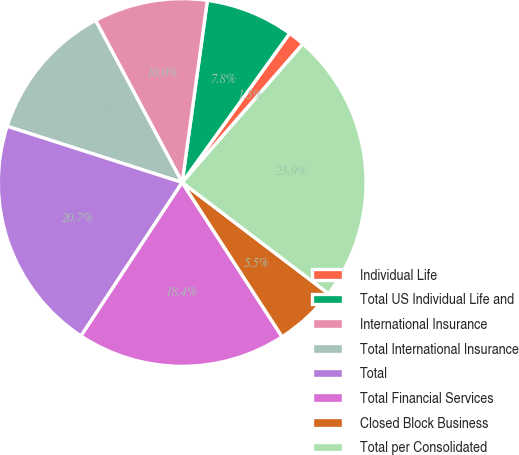Convert chart to OTSL. <chart><loc_0><loc_0><loc_500><loc_500><pie_chart><fcel>Individual Life<fcel>Total US Individual Life and<fcel>International Insurance<fcel>Total International Insurance<fcel>Total<fcel>Total Financial Services<fcel>Closed Block Business<fcel>Total per Consolidated<nl><fcel>1.47%<fcel>7.75%<fcel>10.0%<fcel>12.24%<fcel>20.67%<fcel>18.42%<fcel>5.51%<fcel>23.93%<nl></chart> 